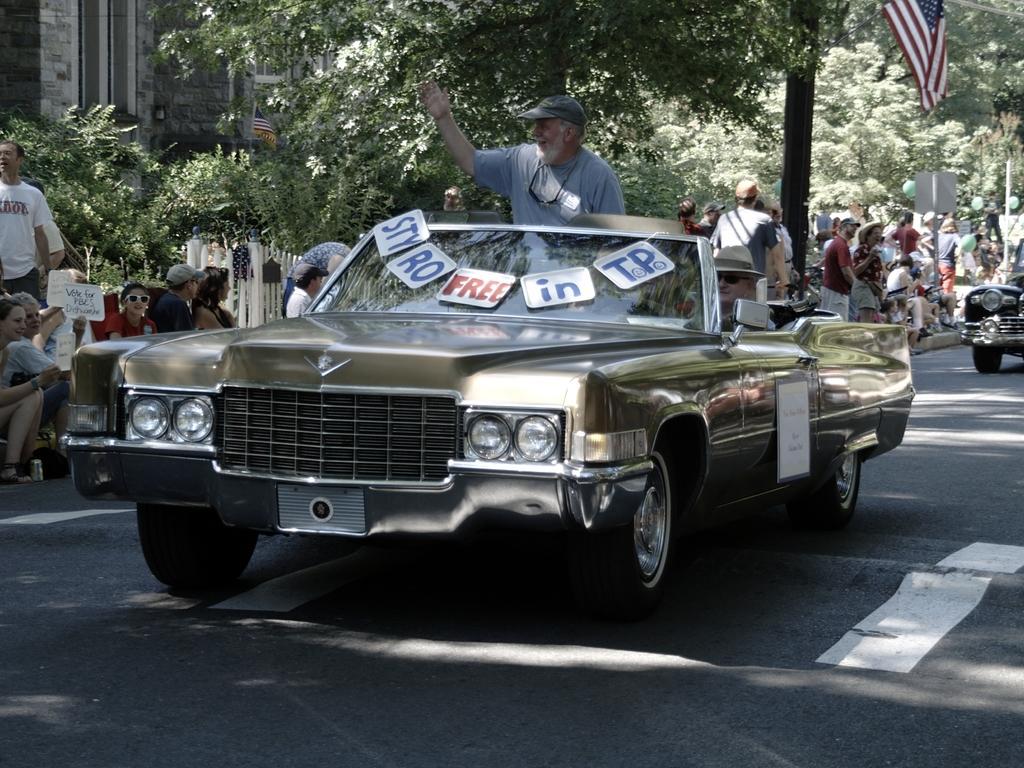In one or two sentences, can you explain what this image depicts? This a picture consist of a car On the road and there is a man stand on the car. And there is a text written on the car and back ground i can see there are some trees and group of persons standing and sitting beside the road and on the right side i can see another car ,on the left side i can see there are some trees and group of persons standing and sitting beside the road. 